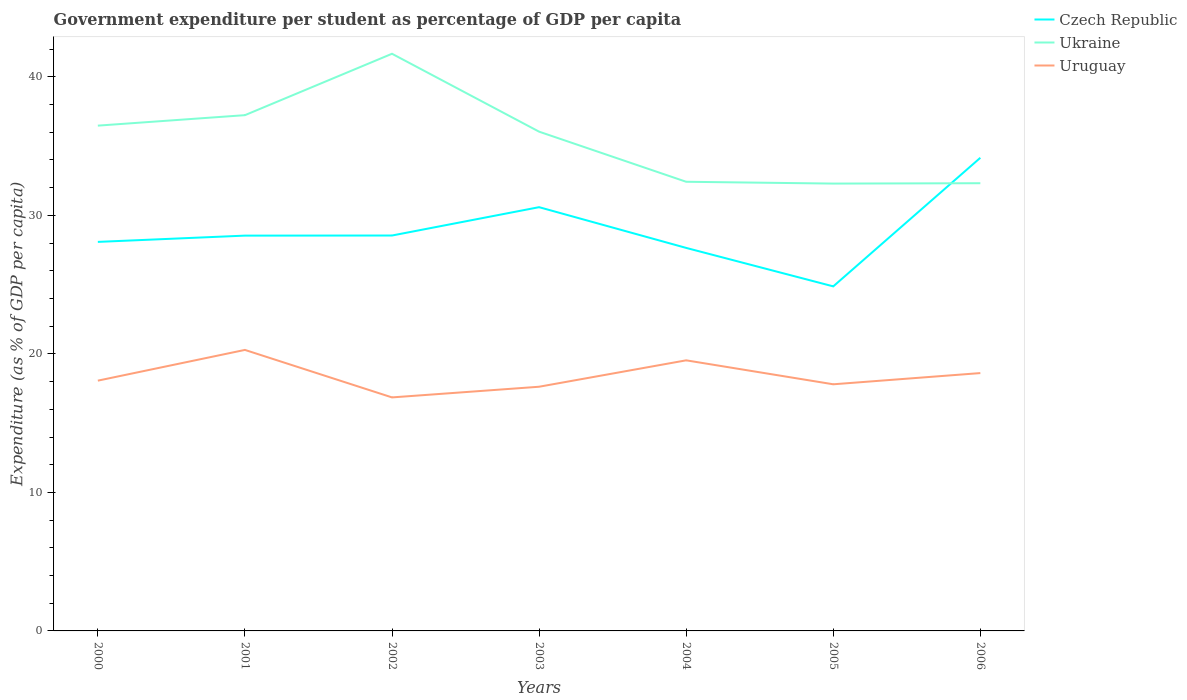Across all years, what is the maximum percentage of expenditure per student in Ukraine?
Provide a short and direct response. 32.3. What is the total percentage of expenditure per student in Czech Republic in the graph?
Provide a succinct answer. -6.07. What is the difference between the highest and the second highest percentage of expenditure per student in Ukraine?
Make the answer very short. 9.37. What is the difference between the highest and the lowest percentage of expenditure per student in Uruguay?
Your answer should be compact. 3. How many years are there in the graph?
Your answer should be compact. 7. What is the difference between two consecutive major ticks on the Y-axis?
Your answer should be compact. 10. Does the graph contain any zero values?
Your answer should be very brief. No. Does the graph contain grids?
Provide a succinct answer. No. Where does the legend appear in the graph?
Provide a succinct answer. Top right. What is the title of the graph?
Offer a terse response. Government expenditure per student as percentage of GDP per capita. Does "Monaco" appear as one of the legend labels in the graph?
Give a very brief answer. No. What is the label or title of the X-axis?
Provide a short and direct response. Years. What is the label or title of the Y-axis?
Keep it short and to the point. Expenditure (as % of GDP per capita). What is the Expenditure (as % of GDP per capita) of Czech Republic in 2000?
Offer a very short reply. 28.09. What is the Expenditure (as % of GDP per capita) in Ukraine in 2000?
Give a very brief answer. 36.48. What is the Expenditure (as % of GDP per capita) in Uruguay in 2000?
Your response must be concise. 18.07. What is the Expenditure (as % of GDP per capita) in Czech Republic in 2001?
Provide a short and direct response. 28.54. What is the Expenditure (as % of GDP per capita) in Ukraine in 2001?
Your answer should be compact. 37.24. What is the Expenditure (as % of GDP per capita) in Uruguay in 2001?
Ensure brevity in your answer.  20.29. What is the Expenditure (as % of GDP per capita) in Czech Republic in 2002?
Offer a very short reply. 28.55. What is the Expenditure (as % of GDP per capita) in Ukraine in 2002?
Keep it short and to the point. 41.67. What is the Expenditure (as % of GDP per capita) of Uruguay in 2002?
Offer a very short reply. 16.86. What is the Expenditure (as % of GDP per capita) of Czech Republic in 2003?
Give a very brief answer. 30.59. What is the Expenditure (as % of GDP per capita) of Ukraine in 2003?
Your answer should be very brief. 36.05. What is the Expenditure (as % of GDP per capita) of Uruguay in 2003?
Offer a very short reply. 17.63. What is the Expenditure (as % of GDP per capita) in Czech Republic in 2004?
Provide a short and direct response. 27.65. What is the Expenditure (as % of GDP per capita) of Ukraine in 2004?
Offer a very short reply. 32.43. What is the Expenditure (as % of GDP per capita) in Uruguay in 2004?
Ensure brevity in your answer.  19.54. What is the Expenditure (as % of GDP per capita) in Czech Republic in 2005?
Offer a very short reply. 24.87. What is the Expenditure (as % of GDP per capita) in Ukraine in 2005?
Your answer should be compact. 32.3. What is the Expenditure (as % of GDP per capita) of Uruguay in 2005?
Your answer should be very brief. 17.81. What is the Expenditure (as % of GDP per capita) of Czech Republic in 2006?
Offer a very short reply. 34.16. What is the Expenditure (as % of GDP per capita) in Ukraine in 2006?
Keep it short and to the point. 32.32. What is the Expenditure (as % of GDP per capita) in Uruguay in 2006?
Your response must be concise. 18.62. Across all years, what is the maximum Expenditure (as % of GDP per capita) of Czech Republic?
Your answer should be compact. 34.16. Across all years, what is the maximum Expenditure (as % of GDP per capita) in Ukraine?
Your response must be concise. 41.67. Across all years, what is the maximum Expenditure (as % of GDP per capita) in Uruguay?
Provide a succinct answer. 20.29. Across all years, what is the minimum Expenditure (as % of GDP per capita) in Czech Republic?
Ensure brevity in your answer.  24.87. Across all years, what is the minimum Expenditure (as % of GDP per capita) in Ukraine?
Your response must be concise. 32.3. Across all years, what is the minimum Expenditure (as % of GDP per capita) in Uruguay?
Keep it short and to the point. 16.86. What is the total Expenditure (as % of GDP per capita) in Czech Republic in the graph?
Ensure brevity in your answer.  202.45. What is the total Expenditure (as % of GDP per capita) of Ukraine in the graph?
Give a very brief answer. 248.48. What is the total Expenditure (as % of GDP per capita) in Uruguay in the graph?
Ensure brevity in your answer.  128.8. What is the difference between the Expenditure (as % of GDP per capita) in Czech Republic in 2000 and that in 2001?
Your response must be concise. -0.45. What is the difference between the Expenditure (as % of GDP per capita) in Ukraine in 2000 and that in 2001?
Make the answer very short. -0.76. What is the difference between the Expenditure (as % of GDP per capita) of Uruguay in 2000 and that in 2001?
Your answer should be compact. -2.22. What is the difference between the Expenditure (as % of GDP per capita) in Czech Republic in 2000 and that in 2002?
Your answer should be compact. -0.46. What is the difference between the Expenditure (as % of GDP per capita) in Ukraine in 2000 and that in 2002?
Your answer should be compact. -5.19. What is the difference between the Expenditure (as % of GDP per capita) in Uruguay in 2000 and that in 2002?
Keep it short and to the point. 1.21. What is the difference between the Expenditure (as % of GDP per capita) in Czech Republic in 2000 and that in 2003?
Your answer should be compact. -2.51. What is the difference between the Expenditure (as % of GDP per capita) in Ukraine in 2000 and that in 2003?
Offer a very short reply. 0.44. What is the difference between the Expenditure (as % of GDP per capita) in Uruguay in 2000 and that in 2003?
Give a very brief answer. 0.44. What is the difference between the Expenditure (as % of GDP per capita) in Czech Republic in 2000 and that in 2004?
Your answer should be very brief. 0.43. What is the difference between the Expenditure (as % of GDP per capita) in Ukraine in 2000 and that in 2004?
Your answer should be compact. 4.05. What is the difference between the Expenditure (as % of GDP per capita) in Uruguay in 2000 and that in 2004?
Keep it short and to the point. -1.47. What is the difference between the Expenditure (as % of GDP per capita) of Czech Republic in 2000 and that in 2005?
Your response must be concise. 3.21. What is the difference between the Expenditure (as % of GDP per capita) in Ukraine in 2000 and that in 2005?
Offer a terse response. 4.18. What is the difference between the Expenditure (as % of GDP per capita) in Uruguay in 2000 and that in 2005?
Offer a terse response. 0.26. What is the difference between the Expenditure (as % of GDP per capita) in Czech Republic in 2000 and that in 2006?
Make the answer very short. -6.07. What is the difference between the Expenditure (as % of GDP per capita) in Ukraine in 2000 and that in 2006?
Provide a short and direct response. 4.16. What is the difference between the Expenditure (as % of GDP per capita) in Uruguay in 2000 and that in 2006?
Give a very brief answer. -0.55. What is the difference between the Expenditure (as % of GDP per capita) of Czech Republic in 2001 and that in 2002?
Your answer should be very brief. -0.01. What is the difference between the Expenditure (as % of GDP per capita) in Ukraine in 2001 and that in 2002?
Make the answer very short. -4.43. What is the difference between the Expenditure (as % of GDP per capita) in Uruguay in 2001 and that in 2002?
Provide a short and direct response. 3.43. What is the difference between the Expenditure (as % of GDP per capita) of Czech Republic in 2001 and that in 2003?
Ensure brevity in your answer.  -2.05. What is the difference between the Expenditure (as % of GDP per capita) in Ukraine in 2001 and that in 2003?
Make the answer very short. 1.19. What is the difference between the Expenditure (as % of GDP per capita) in Uruguay in 2001 and that in 2003?
Your answer should be compact. 2.66. What is the difference between the Expenditure (as % of GDP per capita) in Czech Republic in 2001 and that in 2004?
Your answer should be very brief. 0.89. What is the difference between the Expenditure (as % of GDP per capita) of Ukraine in 2001 and that in 2004?
Your response must be concise. 4.81. What is the difference between the Expenditure (as % of GDP per capita) in Uruguay in 2001 and that in 2004?
Give a very brief answer. 0.75. What is the difference between the Expenditure (as % of GDP per capita) of Czech Republic in 2001 and that in 2005?
Provide a short and direct response. 3.66. What is the difference between the Expenditure (as % of GDP per capita) of Ukraine in 2001 and that in 2005?
Offer a very short reply. 4.94. What is the difference between the Expenditure (as % of GDP per capita) in Uruguay in 2001 and that in 2005?
Your answer should be very brief. 2.48. What is the difference between the Expenditure (as % of GDP per capita) of Czech Republic in 2001 and that in 2006?
Ensure brevity in your answer.  -5.62. What is the difference between the Expenditure (as % of GDP per capita) in Ukraine in 2001 and that in 2006?
Provide a short and direct response. 4.91. What is the difference between the Expenditure (as % of GDP per capita) in Uruguay in 2001 and that in 2006?
Make the answer very short. 1.67. What is the difference between the Expenditure (as % of GDP per capita) in Czech Republic in 2002 and that in 2003?
Your answer should be very brief. -2.05. What is the difference between the Expenditure (as % of GDP per capita) of Ukraine in 2002 and that in 2003?
Ensure brevity in your answer.  5.62. What is the difference between the Expenditure (as % of GDP per capita) of Uruguay in 2002 and that in 2003?
Offer a very short reply. -0.77. What is the difference between the Expenditure (as % of GDP per capita) in Czech Republic in 2002 and that in 2004?
Your response must be concise. 0.89. What is the difference between the Expenditure (as % of GDP per capita) of Ukraine in 2002 and that in 2004?
Provide a succinct answer. 9.24. What is the difference between the Expenditure (as % of GDP per capita) of Uruguay in 2002 and that in 2004?
Keep it short and to the point. -2.68. What is the difference between the Expenditure (as % of GDP per capita) of Czech Republic in 2002 and that in 2005?
Your answer should be compact. 3.67. What is the difference between the Expenditure (as % of GDP per capita) of Ukraine in 2002 and that in 2005?
Provide a short and direct response. 9.37. What is the difference between the Expenditure (as % of GDP per capita) in Uruguay in 2002 and that in 2005?
Your answer should be compact. -0.95. What is the difference between the Expenditure (as % of GDP per capita) in Czech Republic in 2002 and that in 2006?
Provide a short and direct response. -5.61. What is the difference between the Expenditure (as % of GDP per capita) in Ukraine in 2002 and that in 2006?
Your response must be concise. 9.35. What is the difference between the Expenditure (as % of GDP per capita) in Uruguay in 2002 and that in 2006?
Provide a succinct answer. -1.76. What is the difference between the Expenditure (as % of GDP per capita) in Czech Republic in 2003 and that in 2004?
Offer a terse response. 2.94. What is the difference between the Expenditure (as % of GDP per capita) in Ukraine in 2003 and that in 2004?
Make the answer very short. 3.62. What is the difference between the Expenditure (as % of GDP per capita) of Uruguay in 2003 and that in 2004?
Keep it short and to the point. -1.91. What is the difference between the Expenditure (as % of GDP per capita) in Czech Republic in 2003 and that in 2005?
Your response must be concise. 5.72. What is the difference between the Expenditure (as % of GDP per capita) in Ukraine in 2003 and that in 2005?
Make the answer very short. 3.75. What is the difference between the Expenditure (as % of GDP per capita) in Uruguay in 2003 and that in 2005?
Provide a short and direct response. -0.18. What is the difference between the Expenditure (as % of GDP per capita) of Czech Republic in 2003 and that in 2006?
Provide a short and direct response. -3.57. What is the difference between the Expenditure (as % of GDP per capita) of Ukraine in 2003 and that in 2006?
Give a very brief answer. 3.72. What is the difference between the Expenditure (as % of GDP per capita) in Uruguay in 2003 and that in 2006?
Offer a very short reply. -0.99. What is the difference between the Expenditure (as % of GDP per capita) of Czech Republic in 2004 and that in 2005?
Offer a very short reply. 2.78. What is the difference between the Expenditure (as % of GDP per capita) in Ukraine in 2004 and that in 2005?
Your answer should be very brief. 0.13. What is the difference between the Expenditure (as % of GDP per capita) of Uruguay in 2004 and that in 2005?
Make the answer very short. 1.73. What is the difference between the Expenditure (as % of GDP per capita) of Czech Republic in 2004 and that in 2006?
Provide a succinct answer. -6.51. What is the difference between the Expenditure (as % of GDP per capita) of Ukraine in 2004 and that in 2006?
Ensure brevity in your answer.  0.11. What is the difference between the Expenditure (as % of GDP per capita) of Uruguay in 2004 and that in 2006?
Offer a very short reply. 0.92. What is the difference between the Expenditure (as % of GDP per capita) in Czech Republic in 2005 and that in 2006?
Keep it short and to the point. -9.28. What is the difference between the Expenditure (as % of GDP per capita) of Ukraine in 2005 and that in 2006?
Your answer should be very brief. -0.03. What is the difference between the Expenditure (as % of GDP per capita) of Uruguay in 2005 and that in 2006?
Keep it short and to the point. -0.81. What is the difference between the Expenditure (as % of GDP per capita) of Czech Republic in 2000 and the Expenditure (as % of GDP per capita) of Ukraine in 2001?
Offer a very short reply. -9.15. What is the difference between the Expenditure (as % of GDP per capita) in Czech Republic in 2000 and the Expenditure (as % of GDP per capita) in Uruguay in 2001?
Provide a short and direct response. 7.8. What is the difference between the Expenditure (as % of GDP per capita) in Ukraine in 2000 and the Expenditure (as % of GDP per capita) in Uruguay in 2001?
Keep it short and to the point. 16.19. What is the difference between the Expenditure (as % of GDP per capita) in Czech Republic in 2000 and the Expenditure (as % of GDP per capita) in Ukraine in 2002?
Provide a short and direct response. -13.58. What is the difference between the Expenditure (as % of GDP per capita) in Czech Republic in 2000 and the Expenditure (as % of GDP per capita) in Uruguay in 2002?
Make the answer very short. 11.23. What is the difference between the Expenditure (as % of GDP per capita) of Ukraine in 2000 and the Expenditure (as % of GDP per capita) of Uruguay in 2002?
Provide a succinct answer. 19.62. What is the difference between the Expenditure (as % of GDP per capita) of Czech Republic in 2000 and the Expenditure (as % of GDP per capita) of Ukraine in 2003?
Provide a short and direct response. -7.96. What is the difference between the Expenditure (as % of GDP per capita) of Czech Republic in 2000 and the Expenditure (as % of GDP per capita) of Uruguay in 2003?
Make the answer very short. 10.46. What is the difference between the Expenditure (as % of GDP per capita) in Ukraine in 2000 and the Expenditure (as % of GDP per capita) in Uruguay in 2003?
Ensure brevity in your answer.  18.85. What is the difference between the Expenditure (as % of GDP per capita) in Czech Republic in 2000 and the Expenditure (as % of GDP per capita) in Ukraine in 2004?
Offer a terse response. -4.34. What is the difference between the Expenditure (as % of GDP per capita) of Czech Republic in 2000 and the Expenditure (as % of GDP per capita) of Uruguay in 2004?
Your response must be concise. 8.55. What is the difference between the Expenditure (as % of GDP per capita) of Ukraine in 2000 and the Expenditure (as % of GDP per capita) of Uruguay in 2004?
Ensure brevity in your answer.  16.94. What is the difference between the Expenditure (as % of GDP per capita) in Czech Republic in 2000 and the Expenditure (as % of GDP per capita) in Ukraine in 2005?
Provide a succinct answer. -4.21. What is the difference between the Expenditure (as % of GDP per capita) of Czech Republic in 2000 and the Expenditure (as % of GDP per capita) of Uruguay in 2005?
Your response must be concise. 10.28. What is the difference between the Expenditure (as % of GDP per capita) of Ukraine in 2000 and the Expenditure (as % of GDP per capita) of Uruguay in 2005?
Provide a succinct answer. 18.67. What is the difference between the Expenditure (as % of GDP per capita) of Czech Republic in 2000 and the Expenditure (as % of GDP per capita) of Ukraine in 2006?
Make the answer very short. -4.24. What is the difference between the Expenditure (as % of GDP per capita) in Czech Republic in 2000 and the Expenditure (as % of GDP per capita) in Uruguay in 2006?
Make the answer very short. 9.47. What is the difference between the Expenditure (as % of GDP per capita) of Ukraine in 2000 and the Expenditure (as % of GDP per capita) of Uruguay in 2006?
Your answer should be compact. 17.86. What is the difference between the Expenditure (as % of GDP per capita) in Czech Republic in 2001 and the Expenditure (as % of GDP per capita) in Ukraine in 2002?
Keep it short and to the point. -13.13. What is the difference between the Expenditure (as % of GDP per capita) in Czech Republic in 2001 and the Expenditure (as % of GDP per capita) in Uruguay in 2002?
Offer a very short reply. 11.68. What is the difference between the Expenditure (as % of GDP per capita) of Ukraine in 2001 and the Expenditure (as % of GDP per capita) of Uruguay in 2002?
Offer a terse response. 20.38. What is the difference between the Expenditure (as % of GDP per capita) of Czech Republic in 2001 and the Expenditure (as % of GDP per capita) of Ukraine in 2003?
Ensure brevity in your answer.  -7.51. What is the difference between the Expenditure (as % of GDP per capita) of Czech Republic in 2001 and the Expenditure (as % of GDP per capita) of Uruguay in 2003?
Offer a terse response. 10.91. What is the difference between the Expenditure (as % of GDP per capita) of Ukraine in 2001 and the Expenditure (as % of GDP per capita) of Uruguay in 2003?
Keep it short and to the point. 19.61. What is the difference between the Expenditure (as % of GDP per capita) of Czech Republic in 2001 and the Expenditure (as % of GDP per capita) of Ukraine in 2004?
Your response must be concise. -3.89. What is the difference between the Expenditure (as % of GDP per capita) of Czech Republic in 2001 and the Expenditure (as % of GDP per capita) of Uruguay in 2004?
Give a very brief answer. 9. What is the difference between the Expenditure (as % of GDP per capita) of Ukraine in 2001 and the Expenditure (as % of GDP per capita) of Uruguay in 2004?
Make the answer very short. 17.7. What is the difference between the Expenditure (as % of GDP per capita) in Czech Republic in 2001 and the Expenditure (as % of GDP per capita) in Ukraine in 2005?
Provide a short and direct response. -3.76. What is the difference between the Expenditure (as % of GDP per capita) of Czech Republic in 2001 and the Expenditure (as % of GDP per capita) of Uruguay in 2005?
Give a very brief answer. 10.73. What is the difference between the Expenditure (as % of GDP per capita) of Ukraine in 2001 and the Expenditure (as % of GDP per capita) of Uruguay in 2005?
Offer a very short reply. 19.43. What is the difference between the Expenditure (as % of GDP per capita) of Czech Republic in 2001 and the Expenditure (as % of GDP per capita) of Ukraine in 2006?
Your answer should be compact. -3.78. What is the difference between the Expenditure (as % of GDP per capita) of Czech Republic in 2001 and the Expenditure (as % of GDP per capita) of Uruguay in 2006?
Your answer should be very brief. 9.92. What is the difference between the Expenditure (as % of GDP per capita) of Ukraine in 2001 and the Expenditure (as % of GDP per capita) of Uruguay in 2006?
Make the answer very short. 18.62. What is the difference between the Expenditure (as % of GDP per capita) of Czech Republic in 2002 and the Expenditure (as % of GDP per capita) of Ukraine in 2003?
Give a very brief answer. -7.5. What is the difference between the Expenditure (as % of GDP per capita) of Czech Republic in 2002 and the Expenditure (as % of GDP per capita) of Uruguay in 2003?
Ensure brevity in your answer.  10.92. What is the difference between the Expenditure (as % of GDP per capita) in Ukraine in 2002 and the Expenditure (as % of GDP per capita) in Uruguay in 2003?
Provide a short and direct response. 24.04. What is the difference between the Expenditure (as % of GDP per capita) of Czech Republic in 2002 and the Expenditure (as % of GDP per capita) of Ukraine in 2004?
Keep it short and to the point. -3.88. What is the difference between the Expenditure (as % of GDP per capita) of Czech Republic in 2002 and the Expenditure (as % of GDP per capita) of Uruguay in 2004?
Offer a very short reply. 9.01. What is the difference between the Expenditure (as % of GDP per capita) in Ukraine in 2002 and the Expenditure (as % of GDP per capita) in Uruguay in 2004?
Your answer should be compact. 22.13. What is the difference between the Expenditure (as % of GDP per capita) in Czech Republic in 2002 and the Expenditure (as % of GDP per capita) in Ukraine in 2005?
Ensure brevity in your answer.  -3.75. What is the difference between the Expenditure (as % of GDP per capita) of Czech Republic in 2002 and the Expenditure (as % of GDP per capita) of Uruguay in 2005?
Provide a short and direct response. 10.74. What is the difference between the Expenditure (as % of GDP per capita) in Ukraine in 2002 and the Expenditure (as % of GDP per capita) in Uruguay in 2005?
Ensure brevity in your answer.  23.86. What is the difference between the Expenditure (as % of GDP per capita) of Czech Republic in 2002 and the Expenditure (as % of GDP per capita) of Ukraine in 2006?
Offer a terse response. -3.77. What is the difference between the Expenditure (as % of GDP per capita) of Czech Republic in 2002 and the Expenditure (as % of GDP per capita) of Uruguay in 2006?
Offer a terse response. 9.93. What is the difference between the Expenditure (as % of GDP per capita) of Ukraine in 2002 and the Expenditure (as % of GDP per capita) of Uruguay in 2006?
Offer a very short reply. 23.05. What is the difference between the Expenditure (as % of GDP per capita) in Czech Republic in 2003 and the Expenditure (as % of GDP per capita) in Ukraine in 2004?
Keep it short and to the point. -1.83. What is the difference between the Expenditure (as % of GDP per capita) in Czech Republic in 2003 and the Expenditure (as % of GDP per capita) in Uruguay in 2004?
Provide a short and direct response. 11.06. What is the difference between the Expenditure (as % of GDP per capita) in Ukraine in 2003 and the Expenditure (as % of GDP per capita) in Uruguay in 2004?
Keep it short and to the point. 16.51. What is the difference between the Expenditure (as % of GDP per capita) of Czech Republic in 2003 and the Expenditure (as % of GDP per capita) of Ukraine in 2005?
Offer a very short reply. -1.7. What is the difference between the Expenditure (as % of GDP per capita) in Czech Republic in 2003 and the Expenditure (as % of GDP per capita) in Uruguay in 2005?
Your answer should be very brief. 12.79. What is the difference between the Expenditure (as % of GDP per capita) of Ukraine in 2003 and the Expenditure (as % of GDP per capita) of Uruguay in 2005?
Offer a very short reply. 18.24. What is the difference between the Expenditure (as % of GDP per capita) in Czech Republic in 2003 and the Expenditure (as % of GDP per capita) in Ukraine in 2006?
Ensure brevity in your answer.  -1.73. What is the difference between the Expenditure (as % of GDP per capita) in Czech Republic in 2003 and the Expenditure (as % of GDP per capita) in Uruguay in 2006?
Offer a terse response. 11.98. What is the difference between the Expenditure (as % of GDP per capita) in Ukraine in 2003 and the Expenditure (as % of GDP per capita) in Uruguay in 2006?
Your answer should be very brief. 17.43. What is the difference between the Expenditure (as % of GDP per capita) in Czech Republic in 2004 and the Expenditure (as % of GDP per capita) in Ukraine in 2005?
Offer a terse response. -4.64. What is the difference between the Expenditure (as % of GDP per capita) of Czech Republic in 2004 and the Expenditure (as % of GDP per capita) of Uruguay in 2005?
Your answer should be compact. 9.85. What is the difference between the Expenditure (as % of GDP per capita) of Ukraine in 2004 and the Expenditure (as % of GDP per capita) of Uruguay in 2005?
Offer a terse response. 14.62. What is the difference between the Expenditure (as % of GDP per capita) in Czech Republic in 2004 and the Expenditure (as % of GDP per capita) in Ukraine in 2006?
Keep it short and to the point. -4.67. What is the difference between the Expenditure (as % of GDP per capita) in Czech Republic in 2004 and the Expenditure (as % of GDP per capita) in Uruguay in 2006?
Keep it short and to the point. 9.04. What is the difference between the Expenditure (as % of GDP per capita) of Ukraine in 2004 and the Expenditure (as % of GDP per capita) of Uruguay in 2006?
Offer a terse response. 13.81. What is the difference between the Expenditure (as % of GDP per capita) of Czech Republic in 2005 and the Expenditure (as % of GDP per capita) of Ukraine in 2006?
Your answer should be compact. -7.45. What is the difference between the Expenditure (as % of GDP per capita) in Czech Republic in 2005 and the Expenditure (as % of GDP per capita) in Uruguay in 2006?
Provide a short and direct response. 6.26. What is the difference between the Expenditure (as % of GDP per capita) in Ukraine in 2005 and the Expenditure (as % of GDP per capita) in Uruguay in 2006?
Provide a short and direct response. 13.68. What is the average Expenditure (as % of GDP per capita) in Czech Republic per year?
Offer a terse response. 28.92. What is the average Expenditure (as % of GDP per capita) in Ukraine per year?
Keep it short and to the point. 35.5. What is the average Expenditure (as % of GDP per capita) of Uruguay per year?
Keep it short and to the point. 18.4. In the year 2000, what is the difference between the Expenditure (as % of GDP per capita) in Czech Republic and Expenditure (as % of GDP per capita) in Ukraine?
Ensure brevity in your answer.  -8.39. In the year 2000, what is the difference between the Expenditure (as % of GDP per capita) of Czech Republic and Expenditure (as % of GDP per capita) of Uruguay?
Your answer should be very brief. 10.02. In the year 2000, what is the difference between the Expenditure (as % of GDP per capita) of Ukraine and Expenditure (as % of GDP per capita) of Uruguay?
Offer a very short reply. 18.41. In the year 2001, what is the difference between the Expenditure (as % of GDP per capita) in Czech Republic and Expenditure (as % of GDP per capita) in Ukraine?
Make the answer very short. -8.7. In the year 2001, what is the difference between the Expenditure (as % of GDP per capita) of Czech Republic and Expenditure (as % of GDP per capita) of Uruguay?
Give a very brief answer. 8.25. In the year 2001, what is the difference between the Expenditure (as % of GDP per capita) of Ukraine and Expenditure (as % of GDP per capita) of Uruguay?
Provide a short and direct response. 16.95. In the year 2002, what is the difference between the Expenditure (as % of GDP per capita) in Czech Republic and Expenditure (as % of GDP per capita) in Ukraine?
Ensure brevity in your answer.  -13.12. In the year 2002, what is the difference between the Expenditure (as % of GDP per capita) in Czech Republic and Expenditure (as % of GDP per capita) in Uruguay?
Your response must be concise. 11.69. In the year 2002, what is the difference between the Expenditure (as % of GDP per capita) in Ukraine and Expenditure (as % of GDP per capita) in Uruguay?
Offer a very short reply. 24.81. In the year 2003, what is the difference between the Expenditure (as % of GDP per capita) of Czech Republic and Expenditure (as % of GDP per capita) of Ukraine?
Offer a very short reply. -5.45. In the year 2003, what is the difference between the Expenditure (as % of GDP per capita) of Czech Republic and Expenditure (as % of GDP per capita) of Uruguay?
Provide a succinct answer. 12.96. In the year 2003, what is the difference between the Expenditure (as % of GDP per capita) of Ukraine and Expenditure (as % of GDP per capita) of Uruguay?
Ensure brevity in your answer.  18.42. In the year 2004, what is the difference between the Expenditure (as % of GDP per capita) of Czech Republic and Expenditure (as % of GDP per capita) of Ukraine?
Provide a succinct answer. -4.77. In the year 2004, what is the difference between the Expenditure (as % of GDP per capita) in Czech Republic and Expenditure (as % of GDP per capita) in Uruguay?
Your answer should be compact. 8.12. In the year 2004, what is the difference between the Expenditure (as % of GDP per capita) in Ukraine and Expenditure (as % of GDP per capita) in Uruguay?
Ensure brevity in your answer.  12.89. In the year 2005, what is the difference between the Expenditure (as % of GDP per capita) in Czech Republic and Expenditure (as % of GDP per capita) in Ukraine?
Your answer should be very brief. -7.42. In the year 2005, what is the difference between the Expenditure (as % of GDP per capita) in Czech Republic and Expenditure (as % of GDP per capita) in Uruguay?
Your answer should be compact. 7.07. In the year 2005, what is the difference between the Expenditure (as % of GDP per capita) of Ukraine and Expenditure (as % of GDP per capita) of Uruguay?
Offer a very short reply. 14.49. In the year 2006, what is the difference between the Expenditure (as % of GDP per capita) in Czech Republic and Expenditure (as % of GDP per capita) in Ukraine?
Provide a succinct answer. 1.84. In the year 2006, what is the difference between the Expenditure (as % of GDP per capita) in Czech Republic and Expenditure (as % of GDP per capita) in Uruguay?
Give a very brief answer. 15.54. In the year 2006, what is the difference between the Expenditure (as % of GDP per capita) of Ukraine and Expenditure (as % of GDP per capita) of Uruguay?
Your response must be concise. 13.71. What is the ratio of the Expenditure (as % of GDP per capita) in Czech Republic in 2000 to that in 2001?
Offer a very short reply. 0.98. What is the ratio of the Expenditure (as % of GDP per capita) of Ukraine in 2000 to that in 2001?
Make the answer very short. 0.98. What is the ratio of the Expenditure (as % of GDP per capita) in Uruguay in 2000 to that in 2001?
Provide a succinct answer. 0.89. What is the ratio of the Expenditure (as % of GDP per capita) in Czech Republic in 2000 to that in 2002?
Make the answer very short. 0.98. What is the ratio of the Expenditure (as % of GDP per capita) of Ukraine in 2000 to that in 2002?
Offer a terse response. 0.88. What is the ratio of the Expenditure (as % of GDP per capita) of Uruguay in 2000 to that in 2002?
Give a very brief answer. 1.07. What is the ratio of the Expenditure (as % of GDP per capita) in Czech Republic in 2000 to that in 2003?
Provide a short and direct response. 0.92. What is the ratio of the Expenditure (as % of GDP per capita) in Ukraine in 2000 to that in 2003?
Your answer should be compact. 1.01. What is the ratio of the Expenditure (as % of GDP per capita) of Czech Republic in 2000 to that in 2004?
Offer a very short reply. 1.02. What is the ratio of the Expenditure (as % of GDP per capita) of Uruguay in 2000 to that in 2004?
Offer a terse response. 0.92. What is the ratio of the Expenditure (as % of GDP per capita) in Czech Republic in 2000 to that in 2005?
Provide a succinct answer. 1.13. What is the ratio of the Expenditure (as % of GDP per capita) in Ukraine in 2000 to that in 2005?
Offer a terse response. 1.13. What is the ratio of the Expenditure (as % of GDP per capita) of Uruguay in 2000 to that in 2005?
Give a very brief answer. 1.01. What is the ratio of the Expenditure (as % of GDP per capita) of Czech Republic in 2000 to that in 2006?
Keep it short and to the point. 0.82. What is the ratio of the Expenditure (as % of GDP per capita) of Ukraine in 2000 to that in 2006?
Keep it short and to the point. 1.13. What is the ratio of the Expenditure (as % of GDP per capita) in Uruguay in 2000 to that in 2006?
Offer a terse response. 0.97. What is the ratio of the Expenditure (as % of GDP per capita) in Ukraine in 2001 to that in 2002?
Give a very brief answer. 0.89. What is the ratio of the Expenditure (as % of GDP per capita) in Uruguay in 2001 to that in 2002?
Provide a short and direct response. 1.2. What is the ratio of the Expenditure (as % of GDP per capita) of Czech Republic in 2001 to that in 2003?
Provide a succinct answer. 0.93. What is the ratio of the Expenditure (as % of GDP per capita) of Ukraine in 2001 to that in 2003?
Provide a succinct answer. 1.03. What is the ratio of the Expenditure (as % of GDP per capita) of Uruguay in 2001 to that in 2003?
Your answer should be compact. 1.15. What is the ratio of the Expenditure (as % of GDP per capita) in Czech Republic in 2001 to that in 2004?
Ensure brevity in your answer.  1.03. What is the ratio of the Expenditure (as % of GDP per capita) in Ukraine in 2001 to that in 2004?
Offer a very short reply. 1.15. What is the ratio of the Expenditure (as % of GDP per capita) of Uruguay in 2001 to that in 2004?
Make the answer very short. 1.04. What is the ratio of the Expenditure (as % of GDP per capita) in Czech Republic in 2001 to that in 2005?
Offer a very short reply. 1.15. What is the ratio of the Expenditure (as % of GDP per capita) in Ukraine in 2001 to that in 2005?
Make the answer very short. 1.15. What is the ratio of the Expenditure (as % of GDP per capita) of Uruguay in 2001 to that in 2005?
Provide a succinct answer. 1.14. What is the ratio of the Expenditure (as % of GDP per capita) in Czech Republic in 2001 to that in 2006?
Provide a succinct answer. 0.84. What is the ratio of the Expenditure (as % of GDP per capita) of Ukraine in 2001 to that in 2006?
Your answer should be very brief. 1.15. What is the ratio of the Expenditure (as % of GDP per capita) in Uruguay in 2001 to that in 2006?
Make the answer very short. 1.09. What is the ratio of the Expenditure (as % of GDP per capita) in Czech Republic in 2002 to that in 2003?
Ensure brevity in your answer.  0.93. What is the ratio of the Expenditure (as % of GDP per capita) in Ukraine in 2002 to that in 2003?
Ensure brevity in your answer.  1.16. What is the ratio of the Expenditure (as % of GDP per capita) of Uruguay in 2002 to that in 2003?
Make the answer very short. 0.96. What is the ratio of the Expenditure (as % of GDP per capita) of Czech Republic in 2002 to that in 2004?
Your response must be concise. 1.03. What is the ratio of the Expenditure (as % of GDP per capita) in Ukraine in 2002 to that in 2004?
Make the answer very short. 1.28. What is the ratio of the Expenditure (as % of GDP per capita) in Uruguay in 2002 to that in 2004?
Your answer should be very brief. 0.86. What is the ratio of the Expenditure (as % of GDP per capita) of Czech Republic in 2002 to that in 2005?
Your response must be concise. 1.15. What is the ratio of the Expenditure (as % of GDP per capita) of Ukraine in 2002 to that in 2005?
Your answer should be compact. 1.29. What is the ratio of the Expenditure (as % of GDP per capita) in Uruguay in 2002 to that in 2005?
Your response must be concise. 0.95. What is the ratio of the Expenditure (as % of GDP per capita) of Czech Republic in 2002 to that in 2006?
Keep it short and to the point. 0.84. What is the ratio of the Expenditure (as % of GDP per capita) in Ukraine in 2002 to that in 2006?
Give a very brief answer. 1.29. What is the ratio of the Expenditure (as % of GDP per capita) of Uruguay in 2002 to that in 2006?
Your answer should be very brief. 0.91. What is the ratio of the Expenditure (as % of GDP per capita) in Czech Republic in 2003 to that in 2004?
Provide a succinct answer. 1.11. What is the ratio of the Expenditure (as % of GDP per capita) of Ukraine in 2003 to that in 2004?
Provide a succinct answer. 1.11. What is the ratio of the Expenditure (as % of GDP per capita) of Uruguay in 2003 to that in 2004?
Make the answer very short. 0.9. What is the ratio of the Expenditure (as % of GDP per capita) of Czech Republic in 2003 to that in 2005?
Ensure brevity in your answer.  1.23. What is the ratio of the Expenditure (as % of GDP per capita) in Ukraine in 2003 to that in 2005?
Your response must be concise. 1.12. What is the ratio of the Expenditure (as % of GDP per capita) in Uruguay in 2003 to that in 2005?
Your answer should be very brief. 0.99. What is the ratio of the Expenditure (as % of GDP per capita) of Czech Republic in 2003 to that in 2006?
Make the answer very short. 0.9. What is the ratio of the Expenditure (as % of GDP per capita) of Ukraine in 2003 to that in 2006?
Your response must be concise. 1.12. What is the ratio of the Expenditure (as % of GDP per capita) of Uruguay in 2003 to that in 2006?
Provide a short and direct response. 0.95. What is the ratio of the Expenditure (as % of GDP per capita) in Czech Republic in 2004 to that in 2005?
Your answer should be very brief. 1.11. What is the ratio of the Expenditure (as % of GDP per capita) in Uruguay in 2004 to that in 2005?
Keep it short and to the point. 1.1. What is the ratio of the Expenditure (as % of GDP per capita) of Czech Republic in 2004 to that in 2006?
Offer a terse response. 0.81. What is the ratio of the Expenditure (as % of GDP per capita) in Uruguay in 2004 to that in 2006?
Give a very brief answer. 1.05. What is the ratio of the Expenditure (as % of GDP per capita) in Czech Republic in 2005 to that in 2006?
Give a very brief answer. 0.73. What is the ratio of the Expenditure (as % of GDP per capita) in Uruguay in 2005 to that in 2006?
Give a very brief answer. 0.96. What is the difference between the highest and the second highest Expenditure (as % of GDP per capita) in Czech Republic?
Give a very brief answer. 3.57. What is the difference between the highest and the second highest Expenditure (as % of GDP per capita) of Ukraine?
Keep it short and to the point. 4.43. What is the difference between the highest and the second highest Expenditure (as % of GDP per capita) of Uruguay?
Offer a terse response. 0.75. What is the difference between the highest and the lowest Expenditure (as % of GDP per capita) of Czech Republic?
Your answer should be very brief. 9.28. What is the difference between the highest and the lowest Expenditure (as % of GDP per capita) of Ukraine?
Your answer should be compact. 9.37. What is the difference between the highest and the lowest Expenditure (as % of GDP per capita) of Uruguay?
Offer a very short reply. 3.43. 